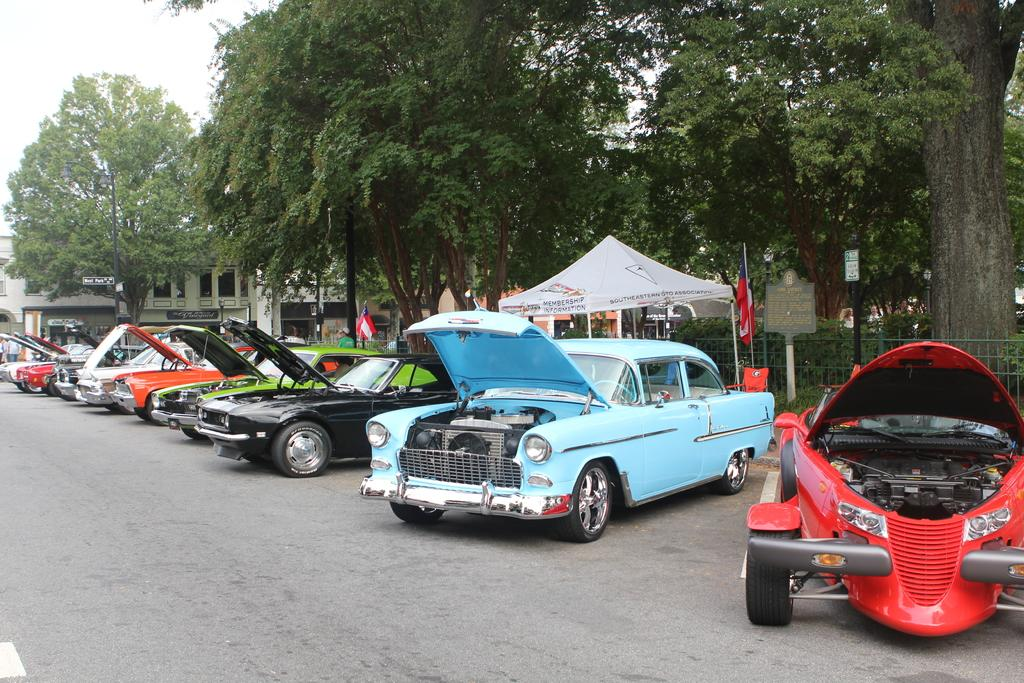What can be seen on the road in the image? There are cars on the road in the image. What is visible in the background of the image? In the background of the image, there is a fence, flags, buildings, a tent, trees, and the sky. How many feet are visible in the image? There are no feet visible in the image. What type of bird can be seen flying in the image? There are no birds visible in the image. 